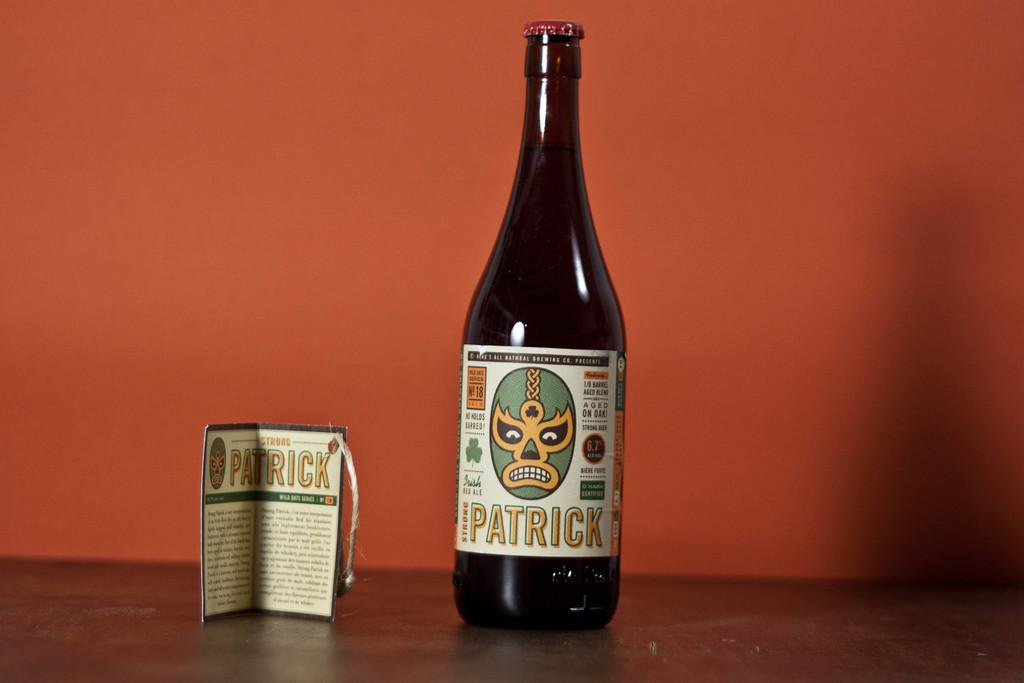Provide a one-sentence caption for the provided image. A bottle of wine with Patrick on the label along with a phamplet about the wine. 